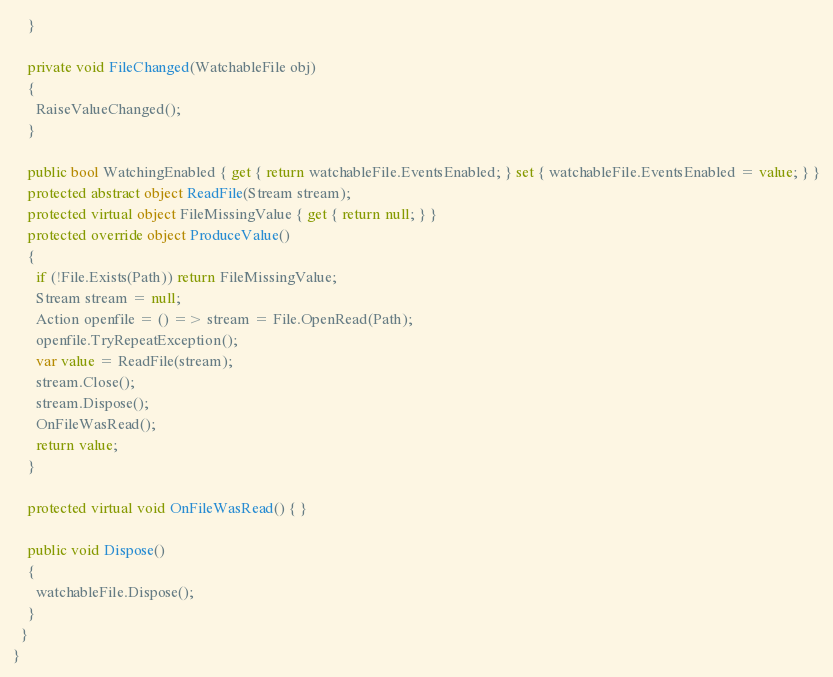<code> <loc_0><loc_0><loc_500><loc_500><_C#_>    }

    private void FileChanged(WatchableFile obj)
    {
      RaiseValueChanged();
    }

    public bool WatchingEnabled { get { return watchableFile.EventsEnabled; } set { watchableFile.EventsEnabled = value; } }
    protected abstract object ReadFile(Stream stream);
    protected virtual object FileMissingValue { get { return null; } }
    protected override object ProduceValue()
    {
      if (!File.Exists(Path)) return FileMissingValue;
      Stream stream = null;
      Action openfile = () => stream = File.OpenRead(Path);
      openfile.TryRepeatException();
      var value = ReadFile(stream);
      stream.Close();
      stream.Dispose();
      OnFileWasRead();
      return value;
    }

    protected virtual void OnFileWasRead() { }

    public void Dispose()
    {
      watchableFile.Dispose();
    }
  }
}
</code> 